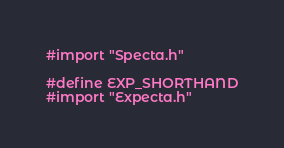<code> <loc_0><loc_0><loc_500><loc_500><_C_>#import "Specta.h"

#define EXP_SHORTHAND
#import "Expecta.h"</code> 